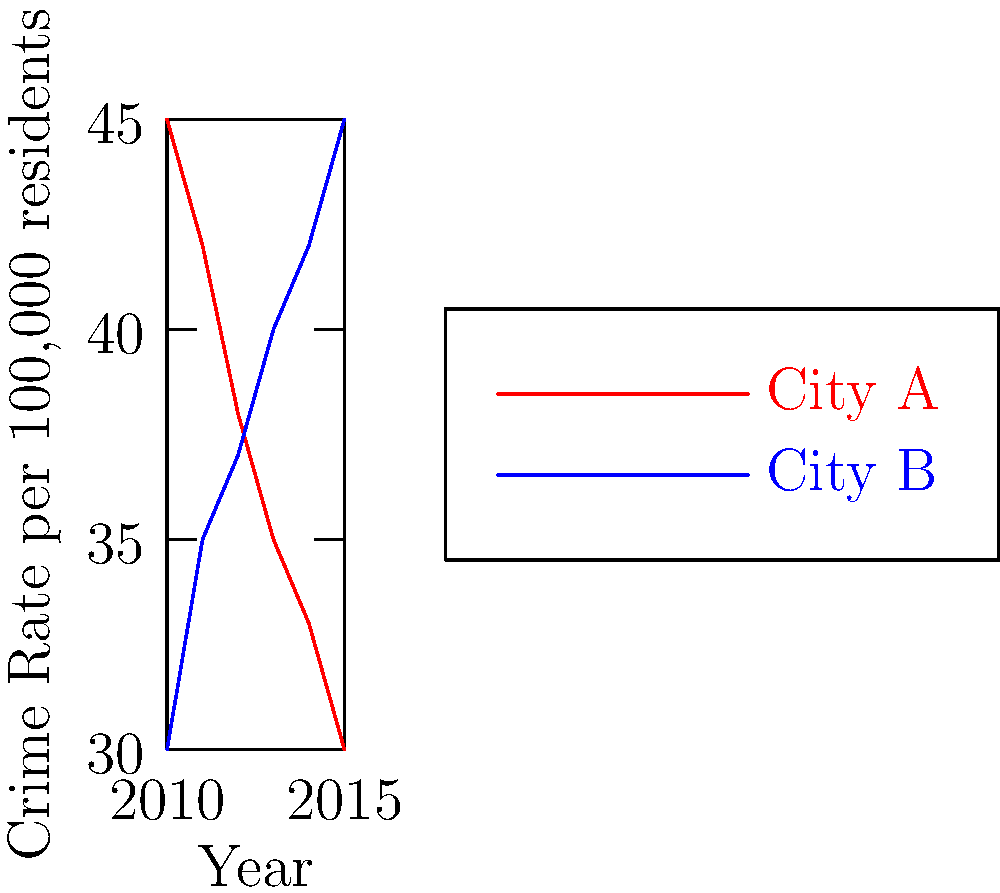As a criminal justice reporter, you're analyzing crime trends in two cities. The graph shows the crime rates per 100,000 residents for City A and City B from 2010 to 2015. In which year did the two cities have approximately the same crime rate, and what was that rate? To solve this problem, we need to follow these steps:

1. Examine the graph to find where the two lines intersect or come very close to each other.
2. The point of intersection represents the year when the crime rates were approximately equal.
3. From the graph, we can see that the lines for City A and City B cross between 2012 and 2013.
4. To find the exact year and rate, we need to estimate the values:

   For 2012:
   City A: approximately 38 per 100,000
   City B: approximately 37 per 100,000

   For 2013:
   City A: approximately 35 per 100,000
   City B: approximately 40 per 100,000

5. The lines appear to intersect closer to 2012, at a rate of about 37.5 per 100,000 residents.

Therefore, the two cities had approximately the same crime rate in 2012, with a rate of about 37.5 per 100,000 residents.
Answer: 2012, approximately 37.5 per 100,000 residents 